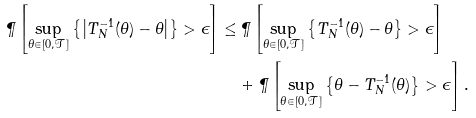Convert formula to latex. <formula><loc_0><loc_0><loc_500><loc_500>\P \left [ \sup _ { \theta \in [ 0 , \mathcal { T } ] } \left \{ \left | T _ { N } ^ { - 1 } ( \theta ) - \theta \right | \right \} > \epsilon \right ] \leq & \, \P \left [ \sup _ { \theta \in [ 0 , \mathcal { T } ] } \left \{ T _ { N } ^ { - 1 } ( \theta ) - \theta \right \} > \epsilon \right ] \\ & + \P \left [ \sup _ { \theta \in [ 0 , \mathcal { T } ] } \left \{ \theta - T _ { N } ^ { - 1 } ( \theta ) \right \} > \epsilon \right ] .</formula> 